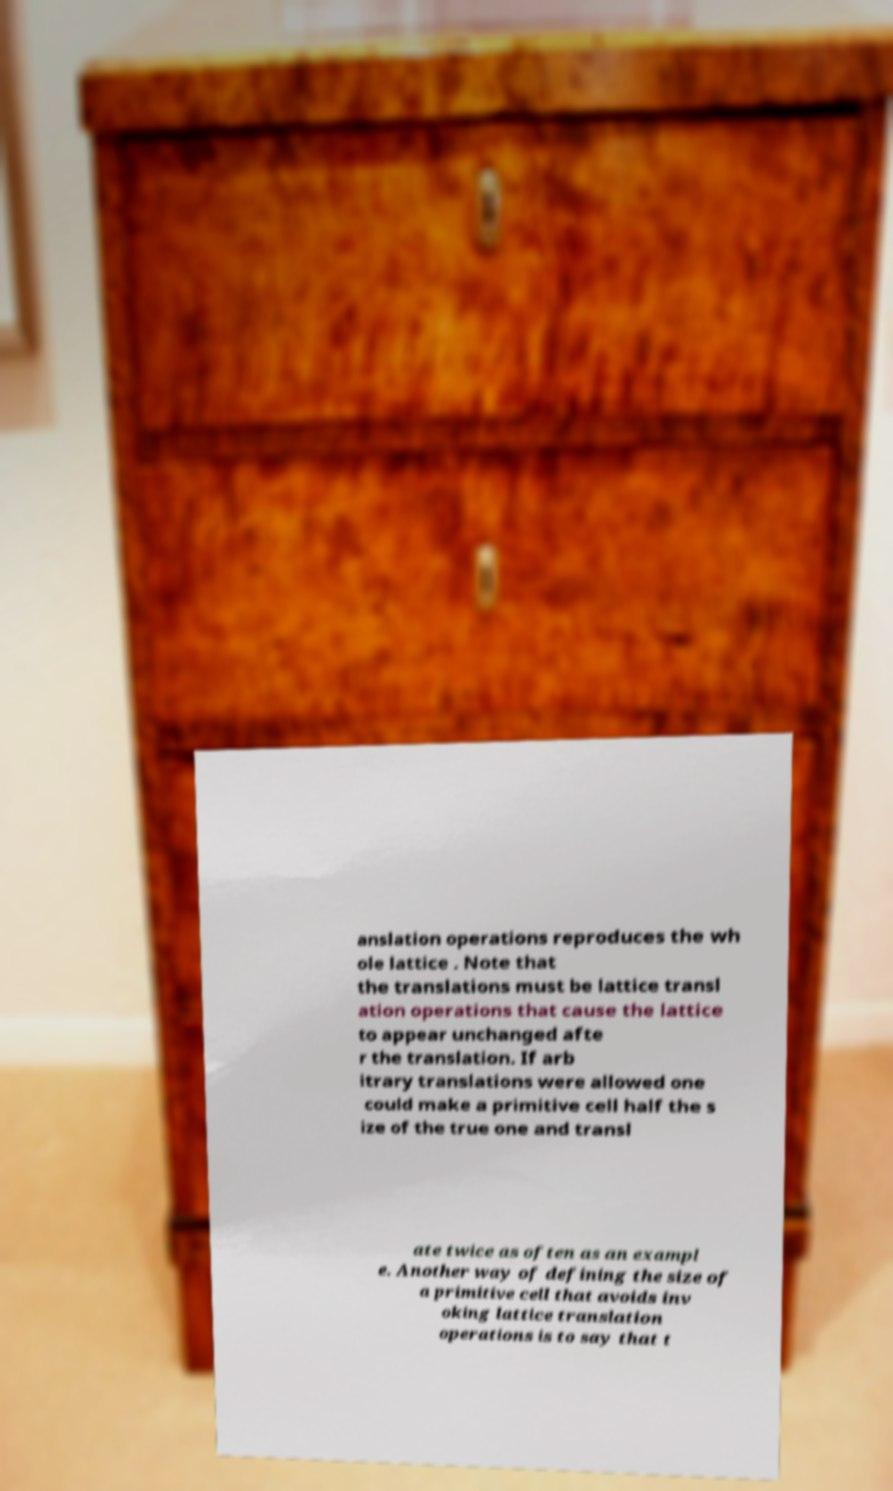Can you read and provide the text displayed in the image?This photo seems to have some interesting text. Can you extract and type it out for me? anslation operations reproduces the wh ole lattice . Note that the translations must be lattice transl ation operations that cause the lattice to appear unchanged afte r the translation. If arb itrary translations were allowed one could make a primitive cell half the s ize of the true one and transl ate twice as often as an exampl e. Another way of defining the size of a primitive cell that avoids inv oking lattice translation operations is to say that t 